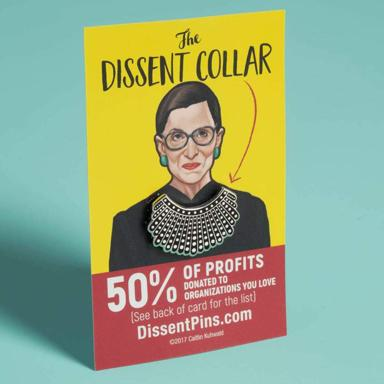Can you tell me more about the charities that benefit from the Dissent Collar sales? The charities that benefit from the sales of the Dissent Collar are chosen by the customers themselves. As stated on the product information, after purchasing the collar, customers can select from a list of organizations that support various causes, including women's rights, social justice, and legal advocacy. These organizations were likely aligned with Justice Ginsburg's values and causes she supported throughout her career. 